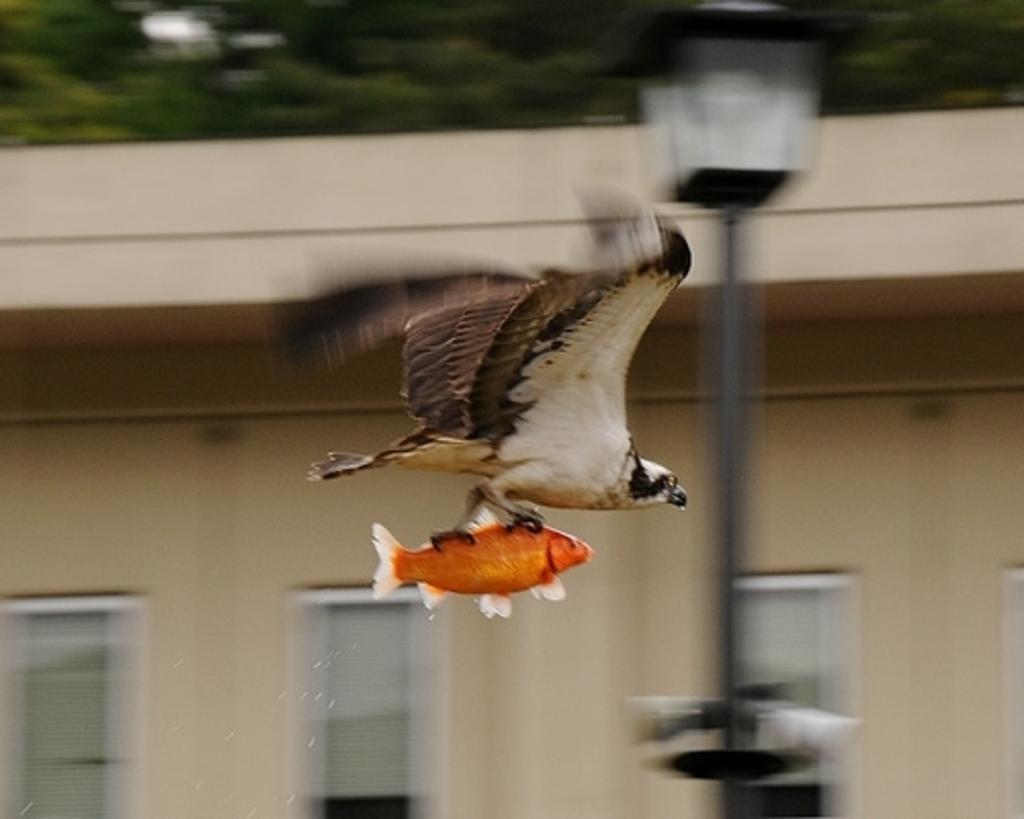Please provide a concise description of this image. In this image there is a bird holding a fish. There is a building in the background. There is a street light. Behind the building there are trees. 